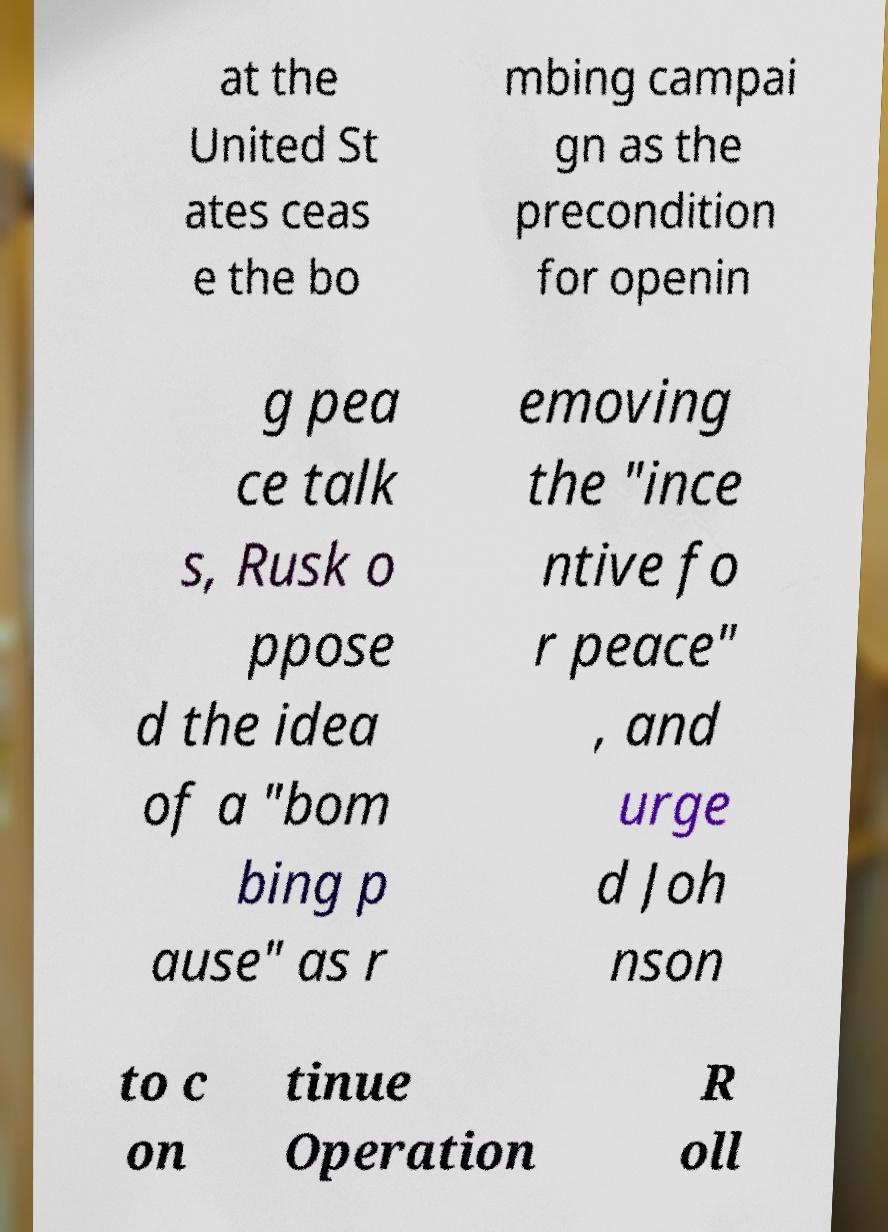Please read and relay the text visible in this image. What does it say? at the United St ates ceas e the bo mbing campai gn as the precondition for openin g pea ce talk s, Rusk o ppose d the idea of a "bom bing p ause" as r emoving the "ince ntive fo r peace" , and urge d Joh nson to c on tinue Operation R oll 